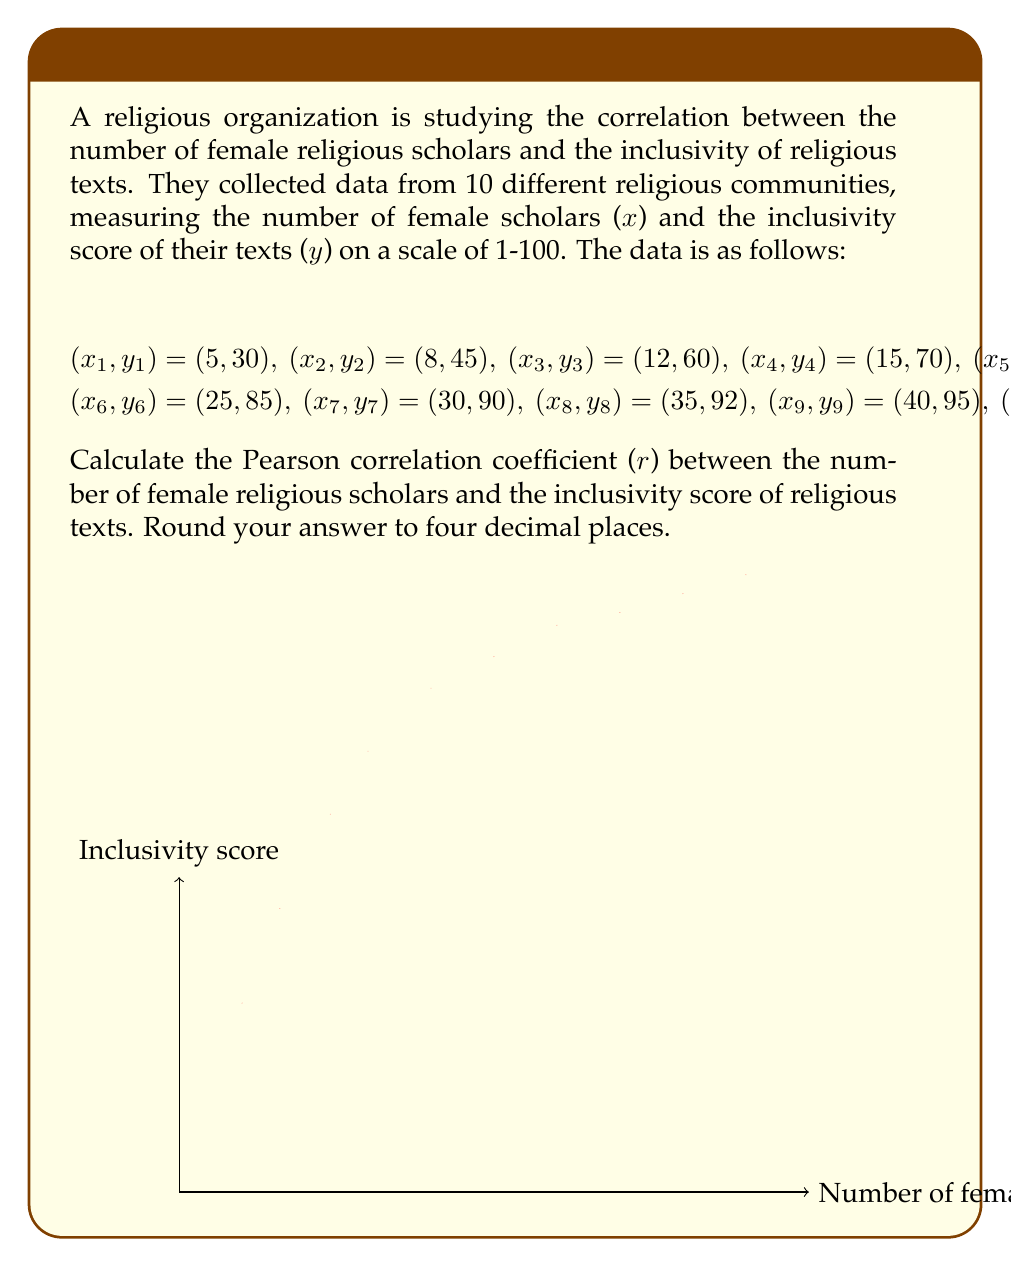Provide a solution to this math problem. To calculate the Pearson correlation coefficient (r), we'll use the formula:

$$r = \frac{n\sum xy - \sum x \sum y}{\sqrt{[n\sum x^2 - (\sum x)^2][n\sum y^2 - (\sum y)^2]}}$$

Step 1: Calculate the sums and squared sums:
$\sum x = 235$
$\sum y = 745$
$\sum xy = 20,635$
$\sum x^2 = 7,275$
$\sum y^2 = 58,275$
$n = 10$

Step 2: Plug these values into the formula:

$$r = \frac{10(20,635) - (235)(745)}{\sqrt{[10(7,275) - 235^2][10(58,275) - 745^2]}}$$

Step 3: Simplify:

$$r = \frac{206,350 - 175,075}{\sqrt{(72,750 - 55,225)(582,750 - 555,025)}}$$

$$r = \frac{31,275}{\sqrt{(17,525)(27,725)}}$$

$$r = \frac{31,275}{\sqrt{485,880,625}}$$

$$r = \frac{31,275}{22,043.14}$$

Step 4: Calculate and round to four decimal places:

$$r \approx 0.9881$$
Answer: $0.9881$ 